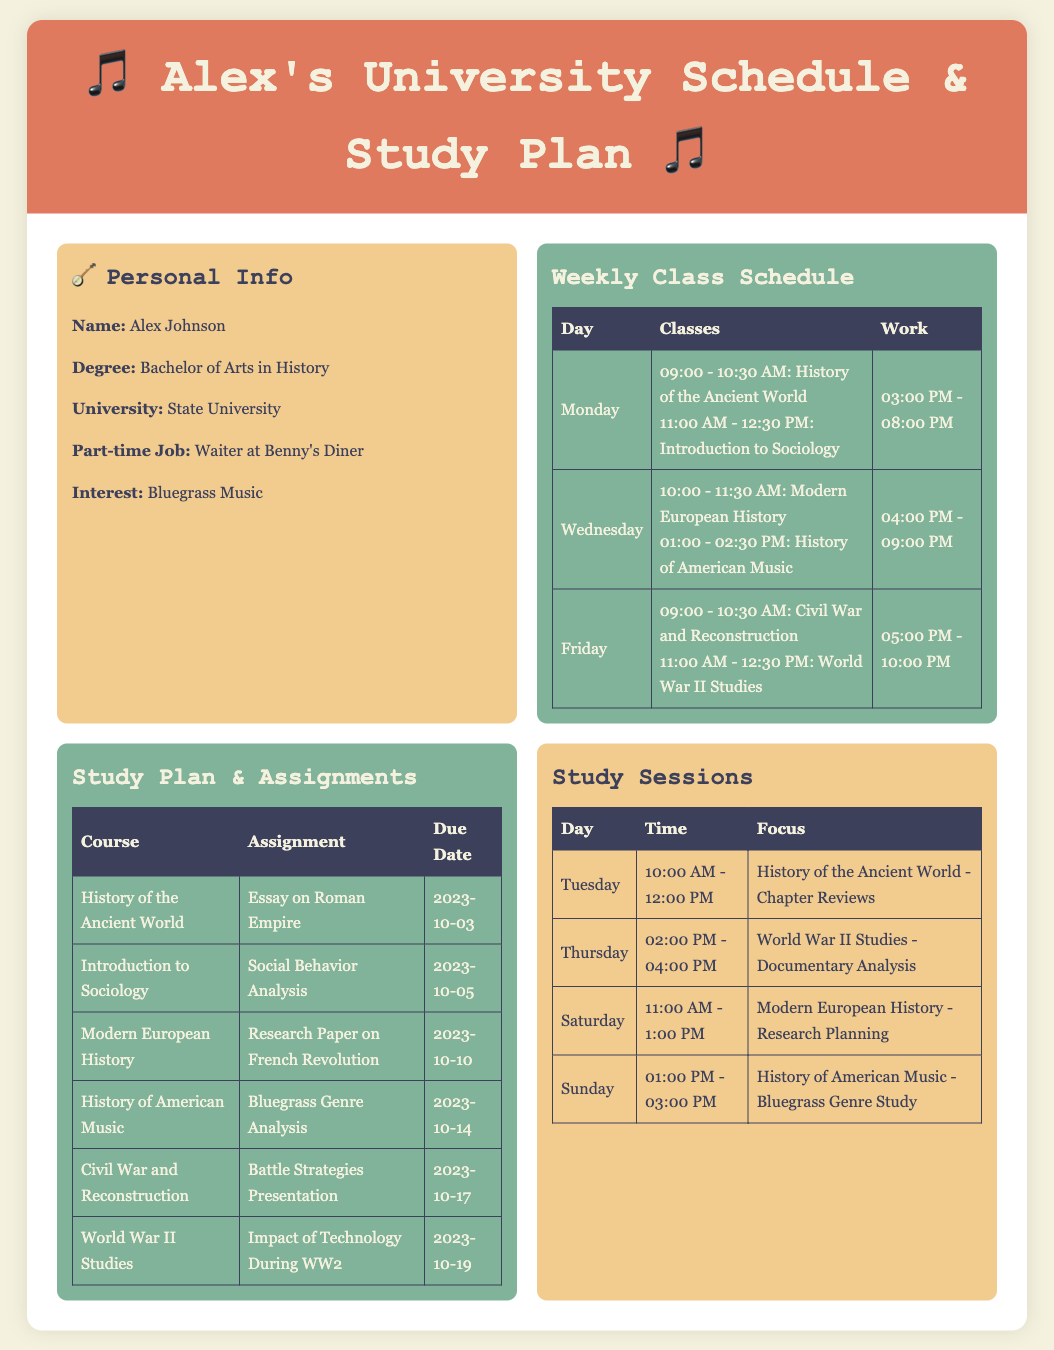What is Alex's degree? Alex is pursuing a Bachelor of Arts in History as indicated in the personal info section.
Answer: Bachelor of Arts in History How many classes does Alex have on Monday? On Monday, Alex has two classes scheduled from 9:00 AM to 12:30 PM, which can be counted from the class schedule table.
Answer: 2 What is the due date for the essay on the Roman Empire? The due date for the essay on the Roman Empire is stated in the study plan section.
Answer: 2023-10-03 What day and time is the study session for Modern European History? The study session for Modern European History is on Saturday from 11:00 AM to 1:00 PM, as noted in the study sessions table.
Answer: Saturday, 11:00 AM - 1:00 PM What time does Alex work on Wednesday? Alex's work schedule on Wednesday is from 4:00 PM to 9:00 PM, as mentioned in the weekly class schedule.
Answer: 4:00 PM - 9:00 PM What is the focus of the study session on Sunday? The focus of the study session on Sunday is indicated as the Bluegrass Genre Study related to History of American Music.
Answer: Bluegrass Genre Study What assignment is due on October 19th? The assignment due on October 19th is specified as the Impact of Technology During WW2.
Answer: Impact of Technology During WW2 How long is the time gap between classes on Friday? The time gap between the classes on Friday is determined by the end of the first class at 10:30 AM and the start of the second class at 11:00 AM, indicating a 30-minute gap.
Answer: 30 minutes 